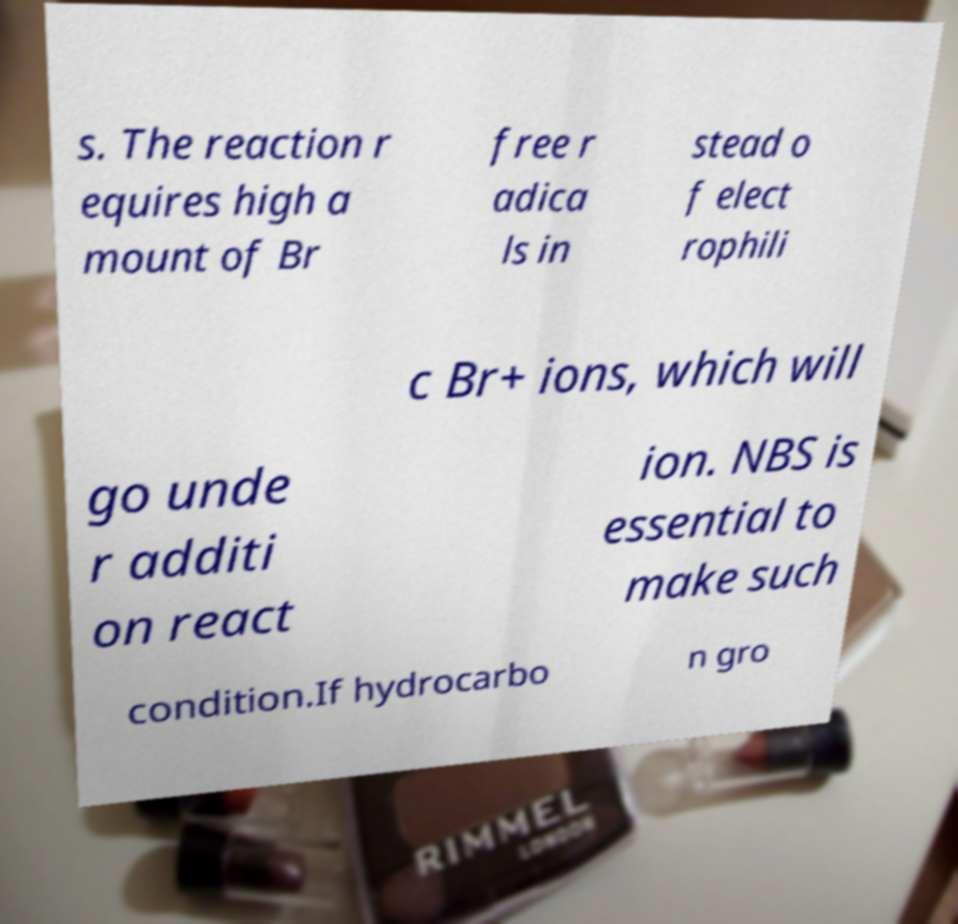Could you assist in decoding the text presented in this image and type it out clearly? s. The reaction r equires high a mount of Br free r adica ls in stead o f elect rophili c Br+ ions, which will go unde r additi on react ion. NBS is essential to make such condition.If hydrocarbo n gro 